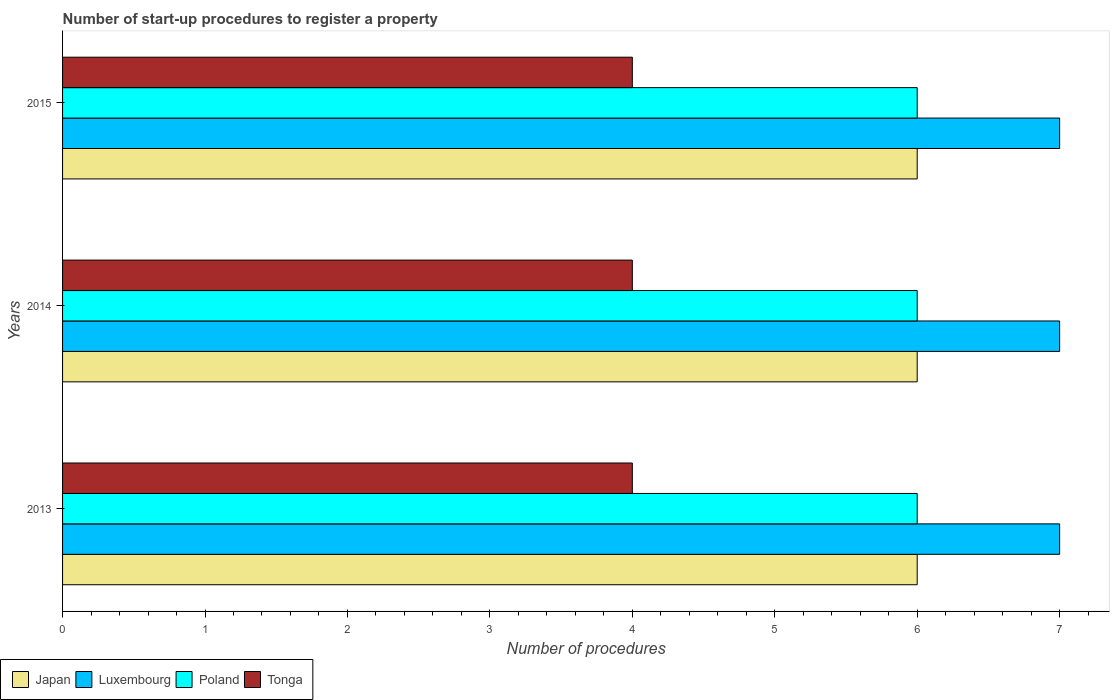Are the number of bars on each tick of the Y-axis equal?
Offer a terse response. Yes. How many bars are there on the 1st tick from the top?
Offer a very short reply. 4. What is the number of procedures required to register a property in Luxembourg in 2015?
Offer a very short reply. 7. Across all years, what is the maximum number of procedures required to register a property in Tonga?
Provide a succinct answer. 4. Across all years, what is the minimum number of procedures required to register a property in Tonga?
Your answer should be compact. 4. In which year was the number of procedures required to register a property in Luxembourg minimum?
Your answer should be compact. 2013. In the year 2015, what is the difference between the number of procedures required to register a property in Japan and number of procedures required to register a property in Poland?
Keep it short and to the point. 0. In how many years, is the number of procedures required to register a property in Tonga greater than 1.6 ?
Your answer should be compact. 3. What is the ratio of the number of procedures required to register a property in Japan in 2014 to that in 2015?
Keep it short and to the point. 1. What is the difference between the highest and the second highest number of procedures required to register a property in Tonga?
Give a very brief answer. 0. In how many years, is the number of procedures required to register a property in Luxembourg greater than the average number of procedures required to register a property in Luxembourg taken over all years?
Offer a very short reply. 0. Is the sum of the number of procedures required to register a property in Tonga in 2013 and 2015 greater than the maximum number of procedures required to register a property in Poland across all years?
Offer a very short reply. Yes. What does the 1st bar from the top in 2014 represents?
Provide a succinct answer. Tonga. What does the 1st bar from the bottom in 2013 represents?
Ensure brevity in your answer.  Japan. How many years are there in the graph?
Give a very brief answer. 3. Are the values on the major ticks of X-axis written in scientific E-notation?
Provide a short and direct response. No. Does the graph contain any zero values?
Ensure brevity in your answer.  No. Where does the legend appear in the graph?
Provide a short and direct response. Bottom left. How many legend labels are there?
Make the answer very short. 4. How are the legend labels stacked?
Offer a terse response. Horizontal. What is the title of the graph?
Ensure brevity in your answer.  Number of start-up procedures to register a property. What is the label or title of the X-axis?
Give a very brief answer. Number of procedures. What is the label or title of the Y-axis?
Your response must be concise. Years. What is the Number of procedures in Japan in 2013?
Give a very brief answer. 6. What is the Number of procedures of Poland in 2013?
Provide a short and direct response. 6. What is the Number of procedures in Tonga in 2013?
Offer a very short reply. 4. What is the Number of procedures in Luxembourg in 2014?
Make the answer very short. 7. What is the Number of procedures in Poland in 2014?
Ensure brevity in your answer.  6. Across all years, what is the maximum Number of procedures of Japan?
Give a very brief answer. 6. Across all years, what is the maximum Number of procedures in Tonga?
Provide a succinct answer. 4. Across all years, what is the minimum Number of procedures in Tonga?
Provide a succinct answer. 4. What is the total Number of procedures in Poland in the graph?
Your response must be concise. 18. What is the difference between the Number of procedures of Japan in 2013 and that in 2014?
Your response must be concise. 0. What is the difference between the Number of procedures of Poland in 2013 and that in 2014?
Make the answer very short. 0. What is the difference between the Number of procedures of Tonga in 2013 and that in 2014?
Your answer should be compact. 0. What is the difference between the Number of procedures in Luxembourg in 2013 and that in 2015?
Your answer should be very brief. 0. What is the difference between the Number of procedures in Poland in 2013 and that in 2015?
Provide a succinct answer. 0. What is the difference between the Number of procedures in Poland in 2014 and that in 2015?
Provide a short and direct response. 0. What is the difference between the Number of procedures of Japan in 2013 and the Number of procedures of Luxembourg in 2014?
Ensure brevity in your answer.  -1. What is the difference between the Number of procedures in Luxembourg in 2013 and the Number of procedures in Tonga in 2014?
Give a very brief answer. 3. What is the difference between the Number of procedures in Japan in 2013 and the Number of procedures in Luxembourg in 2015?
Your answer should be very brief. -1. What is the difference between the Number of procedures in Japan in 2013 and the Number of procedures in Tonga in 2015?
Ensure brevity in your answer.  2. What is the difference between the Number of procedures of Luxembourg in 2013 and the Number of procedures of Poland in 2015?
Provide a succinct answer. 1. What is the difference between the Number of procedures of Luxembourg in 2013 and the Number of procedures of Tonga in 2015?
Give a very brief answer. 3. What is the difference between the Number of procedures in Japan in 2014 and the Number of procedures in Tonga in 2015?
Ensure brevity in your answer.  2. What is the average Number of procedures in Poland per year?
Your answer should be very brief. 6. In the year 2013, what is the difference between the Number of procedures of Japan and Number of procedures of Luxembourg?
Ensure brevity in your answer.  -1. In the year 2013, what is the difference between the Number of procedures of Luxembourg and Number of procedures of Poland?
Your answer should be very brief. 1. In the year 2013, what is the difference between the Number of procedures of Luxembourg and Number of procedures of Tonga?
Provide a short and direct response. 3. In the year 2013, what is the difference between the Number of procedures of Poland and Number of procedures of Tonga?
Give a very brief answer. 2. In the year 2014, what is the difference between the Number of procedures of Luxembourg and Number of procedures of Poland?
Your answer should be compact. 1. In the year 2014, what is the difference between the Number of procedures of Luxembourg and Number of procedures of Tonga?
Offer a terse response. 3. In the year 2014, what is the difference between the Number of procedures in Poland and Number of procedures in Tonga?
Offer a terse response. 2. In the year 2015, what is the difference between the Number of procedures in Japan and Number of procedures in Luxembourg?
Your response must be concise. -1. In the year 2015, what is the difference between the Number of procedures of Japan and Number of procedures of Poland?
Your answer should be compact. 0. In the year 2015, what is the difference between the Number of procedures of Luxembourg and Number of procedures of Poland?
Offer a terse response. 1. In the year 2015, what is the difference between the Number of procedures of Poland and Number of procedures of Tonga?
Give a very brief answer. 2. What is the ratio of the Number of procedures in Japan in 2013 to that in 2014?
Your answer should be compact. 1. What is the ratio of the Number of procedures in Luxembourg in 2013 to that in 2014?
Your answer should be compact. 1. What is the ratio of the Number of procedures in Japan in 2013 to that in 2015?
Your response must be concise. 1. What is the ratio of the Number of procedures of Luxembourg in 2013 to that in 2015?
Ensure brevity in your answer.  1. What is the ratio of the Number of procedures of Poland in 2013 to that in 2015?
Ensure brevity in your answer.  1. What is the ratio of the Number of procedures of Japan in 2014 to that in 2015?
Offer a very short reply. 1. What is the ratio of the Number of procedures of Poland in 2014 to that in 2015?
Your response must be concise. 1. What is the ratio of the Number of procedures in Tonga in 2014 to that in 2015?
Provide a succinct answer. 1. What is the difference between the highest and the second highest Number of procedures of Japan?
Your answer should be compact. 0. What is the difference between the highest and the second highest Number of procedures of Poland?
Offer a terse response. 0. What is the difference between the highest and the second highest Number of procedures in Tonga?
Make the answer very short. 0. What is the difference between the highest and the lowest Number of procedures in Japan?
Give a very brief answer. 0. 